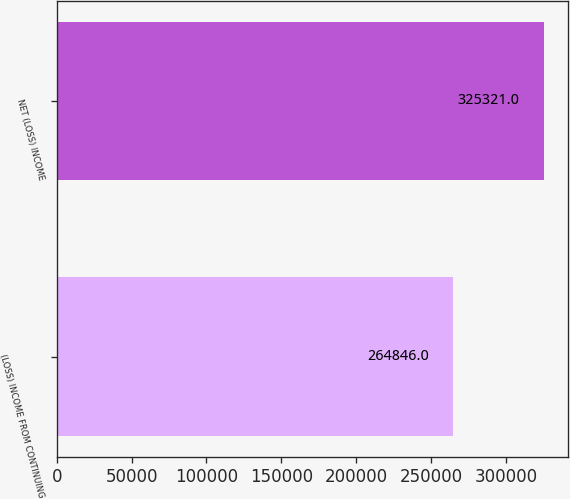<chart> <loc_0><loc_0><loc_500><loc_500><bar_chart><fcel>(LOSS) INCOME FROM CONTINUING<fcel>NET (LOSS) INCOME<nl><fcel>264846<fcel>325321<nl></chart> 